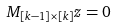<formula> <loc_0><loc_0><loc_500><loc_500>M _ { [ k - 1 ] \times [ k ] } z = 0</formula> 